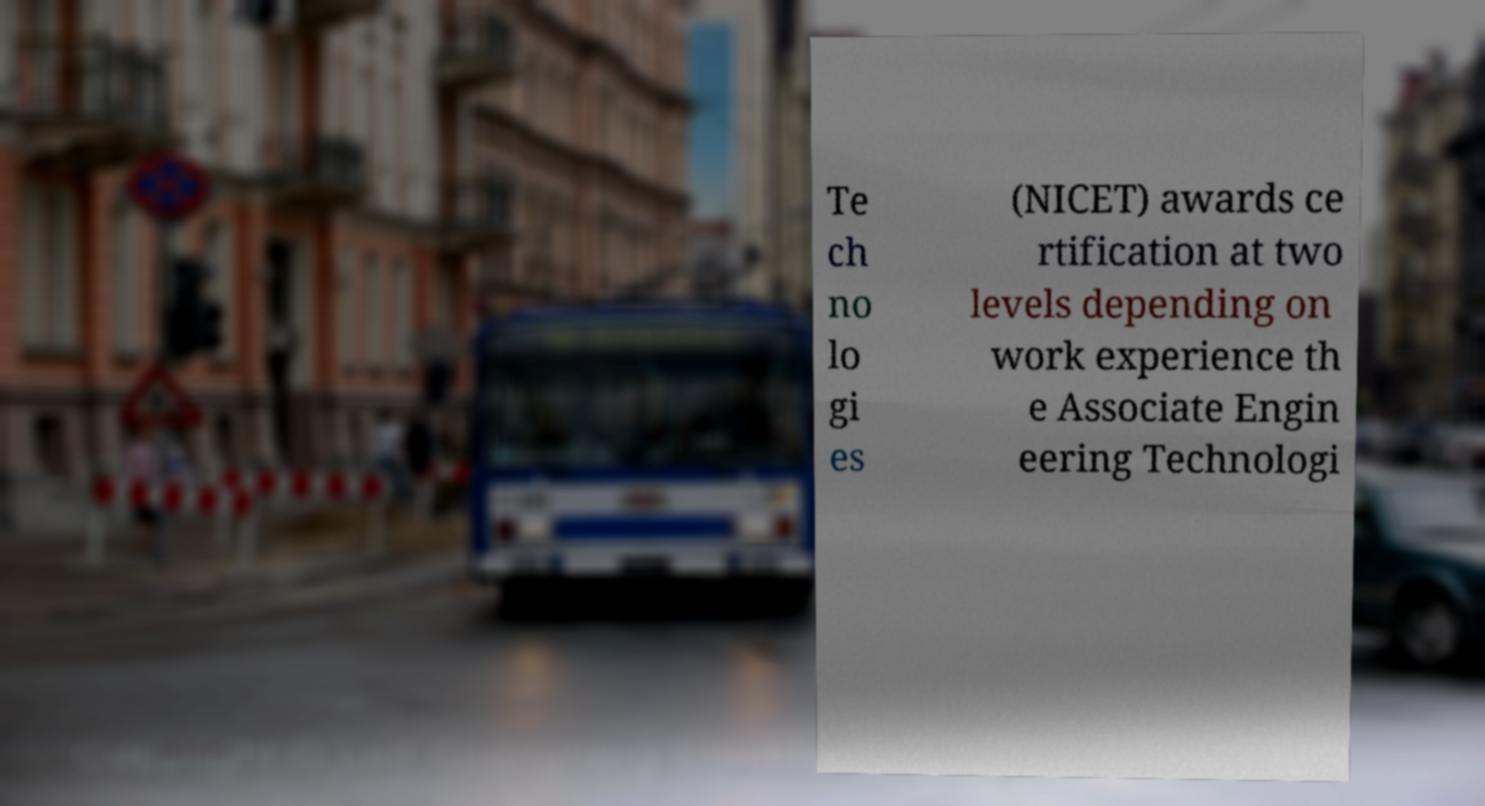Can you read and provide the text displayed in the image?This photo seems to have some interesting text. Can you extract and type it out for me? Te ch no lo gi es (NICET) awards ce rtification at two levels depending on work experience th e Associate Engin eering Technologi 